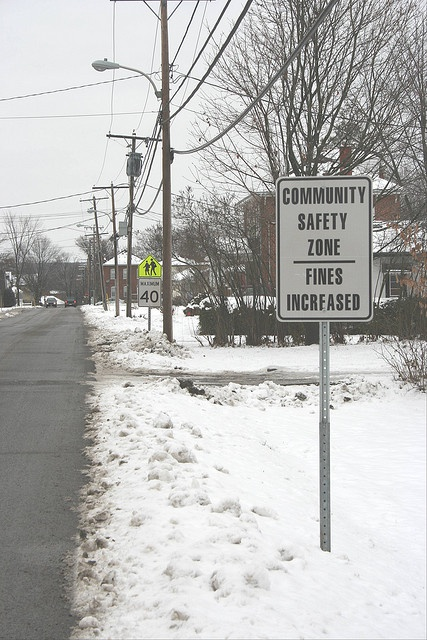Describe the objects in this image and their specific colors. I can see car in lightgray, gray, black, and brown tones and car in lightgray, gray, and black tones in this image. 